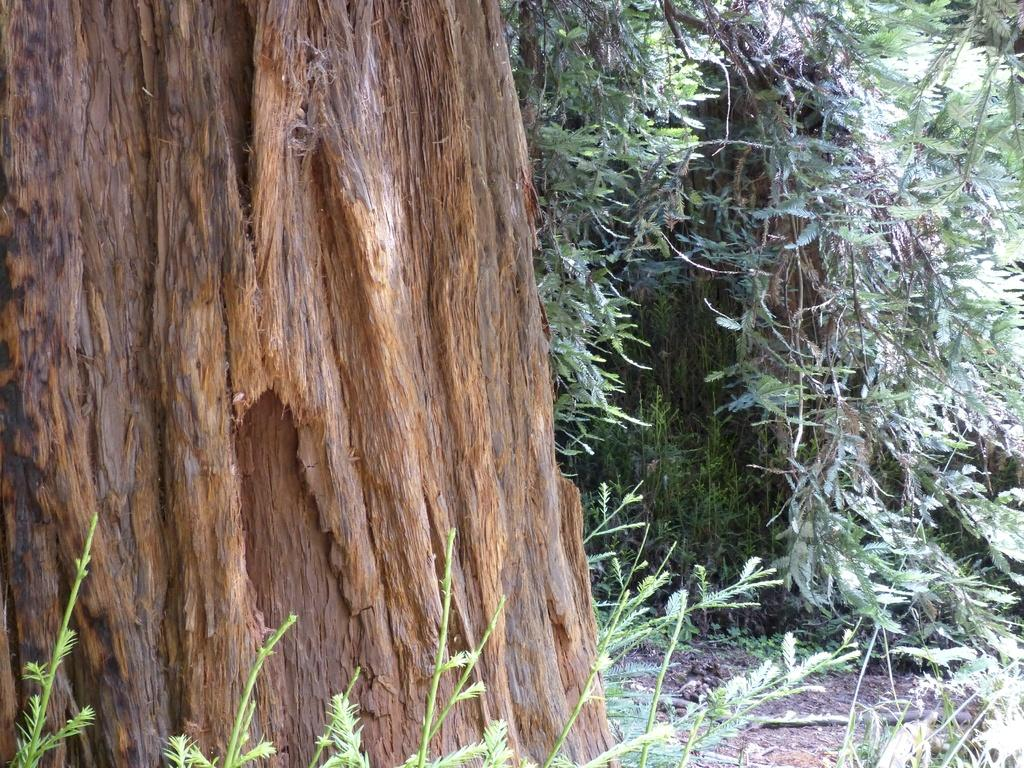What is the main subject of the image? The main subject of the image is a tree trunk. Are there any other trees visible in the image? Yes, there are trees in the image. What type of vegetation can be seen at the bottom of the image? There are plants at the bottom of the image. What type of church can be seen in the image? There is no church present in the image; it features a tree trunk and other vegetation. How does the tree trunk affect the mind of the viewer in the image? The image does not depict any emotions or mental states, so it is not possible to determine how the tree trunk might affect the viewer's mind. 